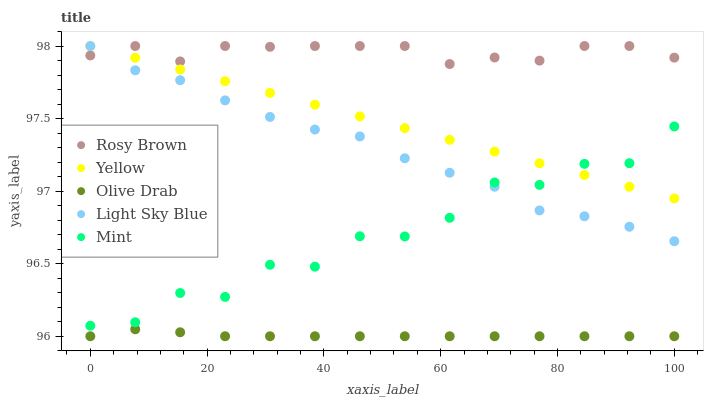Does Olive Drab have the minimum area under the curve?
Answer yes or no. Yes. Does Rosy Brown have the maximum area under the curve?
Answer yes or no. Yes. Does Mint have the minimum area under the curve?
Answer yes or no. No. Does Mint have the maximum area under the curve?
Answer yes or no. No. Is Yellow the smoothest?
Answer yes or no. Yes. Is Mint the roughest?
Answer yes or no. Yes. Is Olive Drab the smoothest?
Answer yes or no. No. Is Olive Drab the roughest?
Answer yes or no. No. Does Olive Drab have the lowest value?
Answer yes or no. Yes. Does Mint have the lowest value?
Answer yes or no. No. Does Light Sky Blue have the highest value?
Answer yes or no. Yes. Does Mint have the highest value?
Answer yes or no. No. Is Olive Drab less than Light Sky Blue?
Answer yes or no. Yes. Is Mint greater than Olive Drab?
Answer yes or no. Yes. Does Rosy Brown intersect Yellow?
Answer yes or no. Yes. Is Rosy Brown less than Yellow?
Answer yes or no. No. Is Rosy Brown greater than Yellow?
Answer yes or no. No. Does Olive Drab intersect Light Sky Blue?
Answer yes or no. No. 